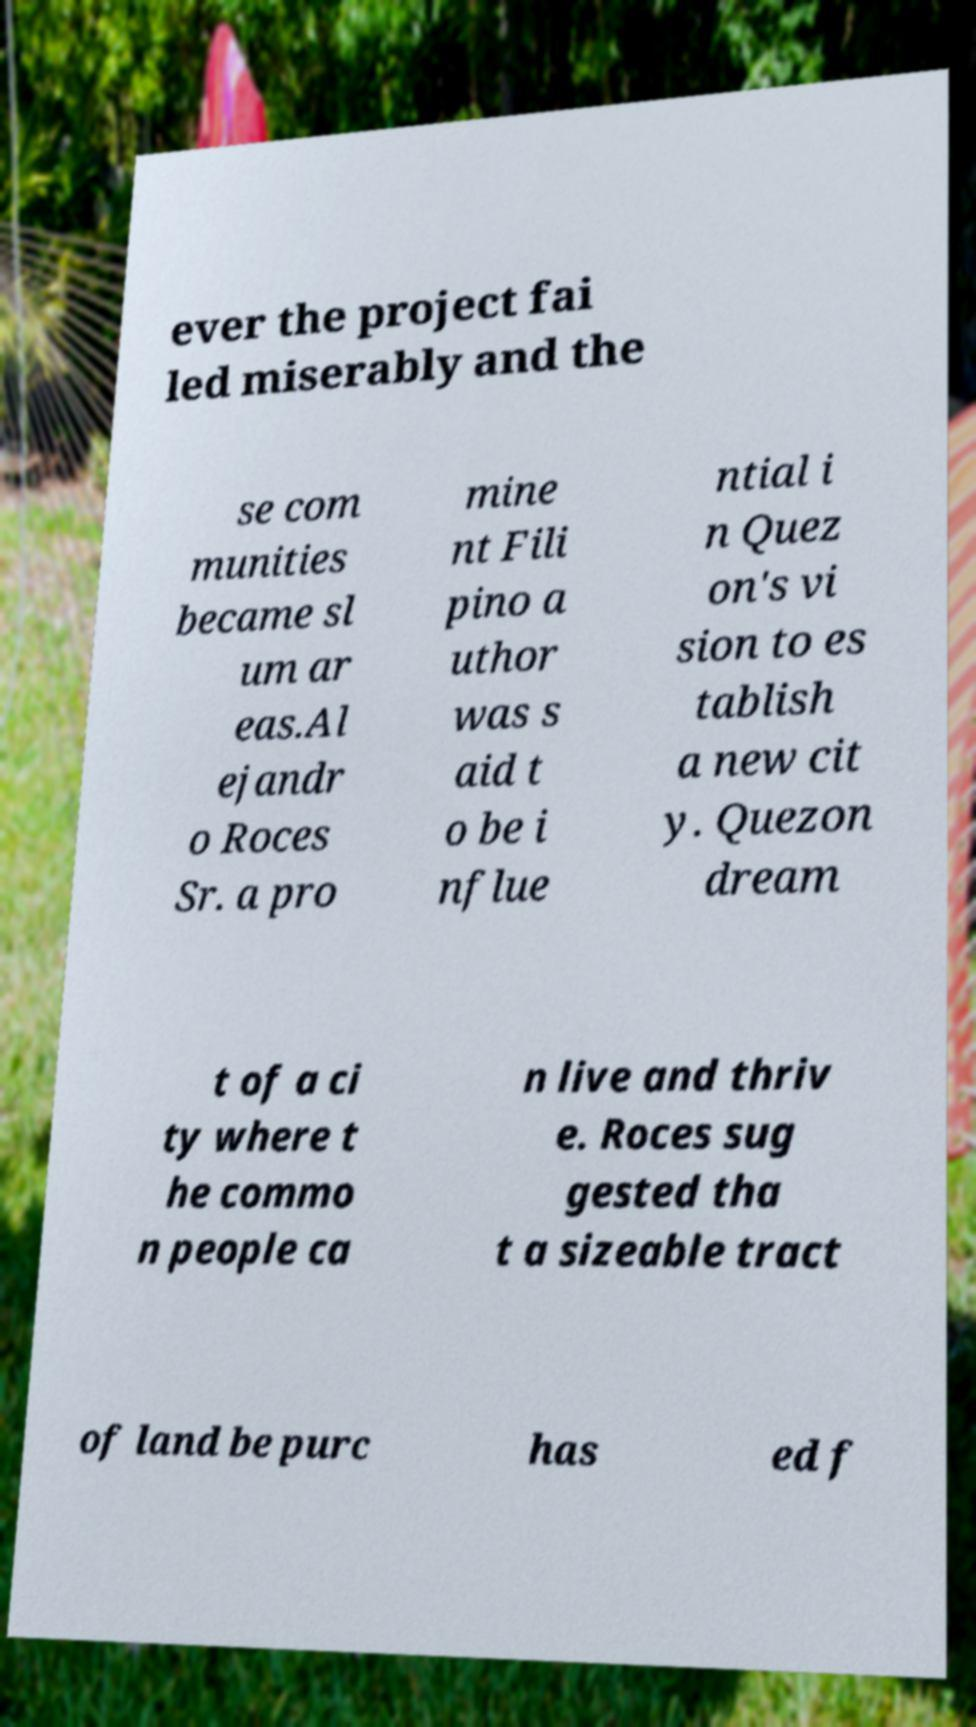What messages or text are displayed in this image? I need them in a readable, typed format. ever the project fai led miserably and the se com munities became sl um ar eas.Al ejandr o Roces Sr. a pro mine nt Fili pino a uthor was s aid t o be i nflue ntial i n Quez on's vi sion to es tablish a new cit y. Quezon dream t of a ci ty where t he commo n people ca n live and thriv e. Roces sug gested tha t a sizeable tract of land be purc has ed f 